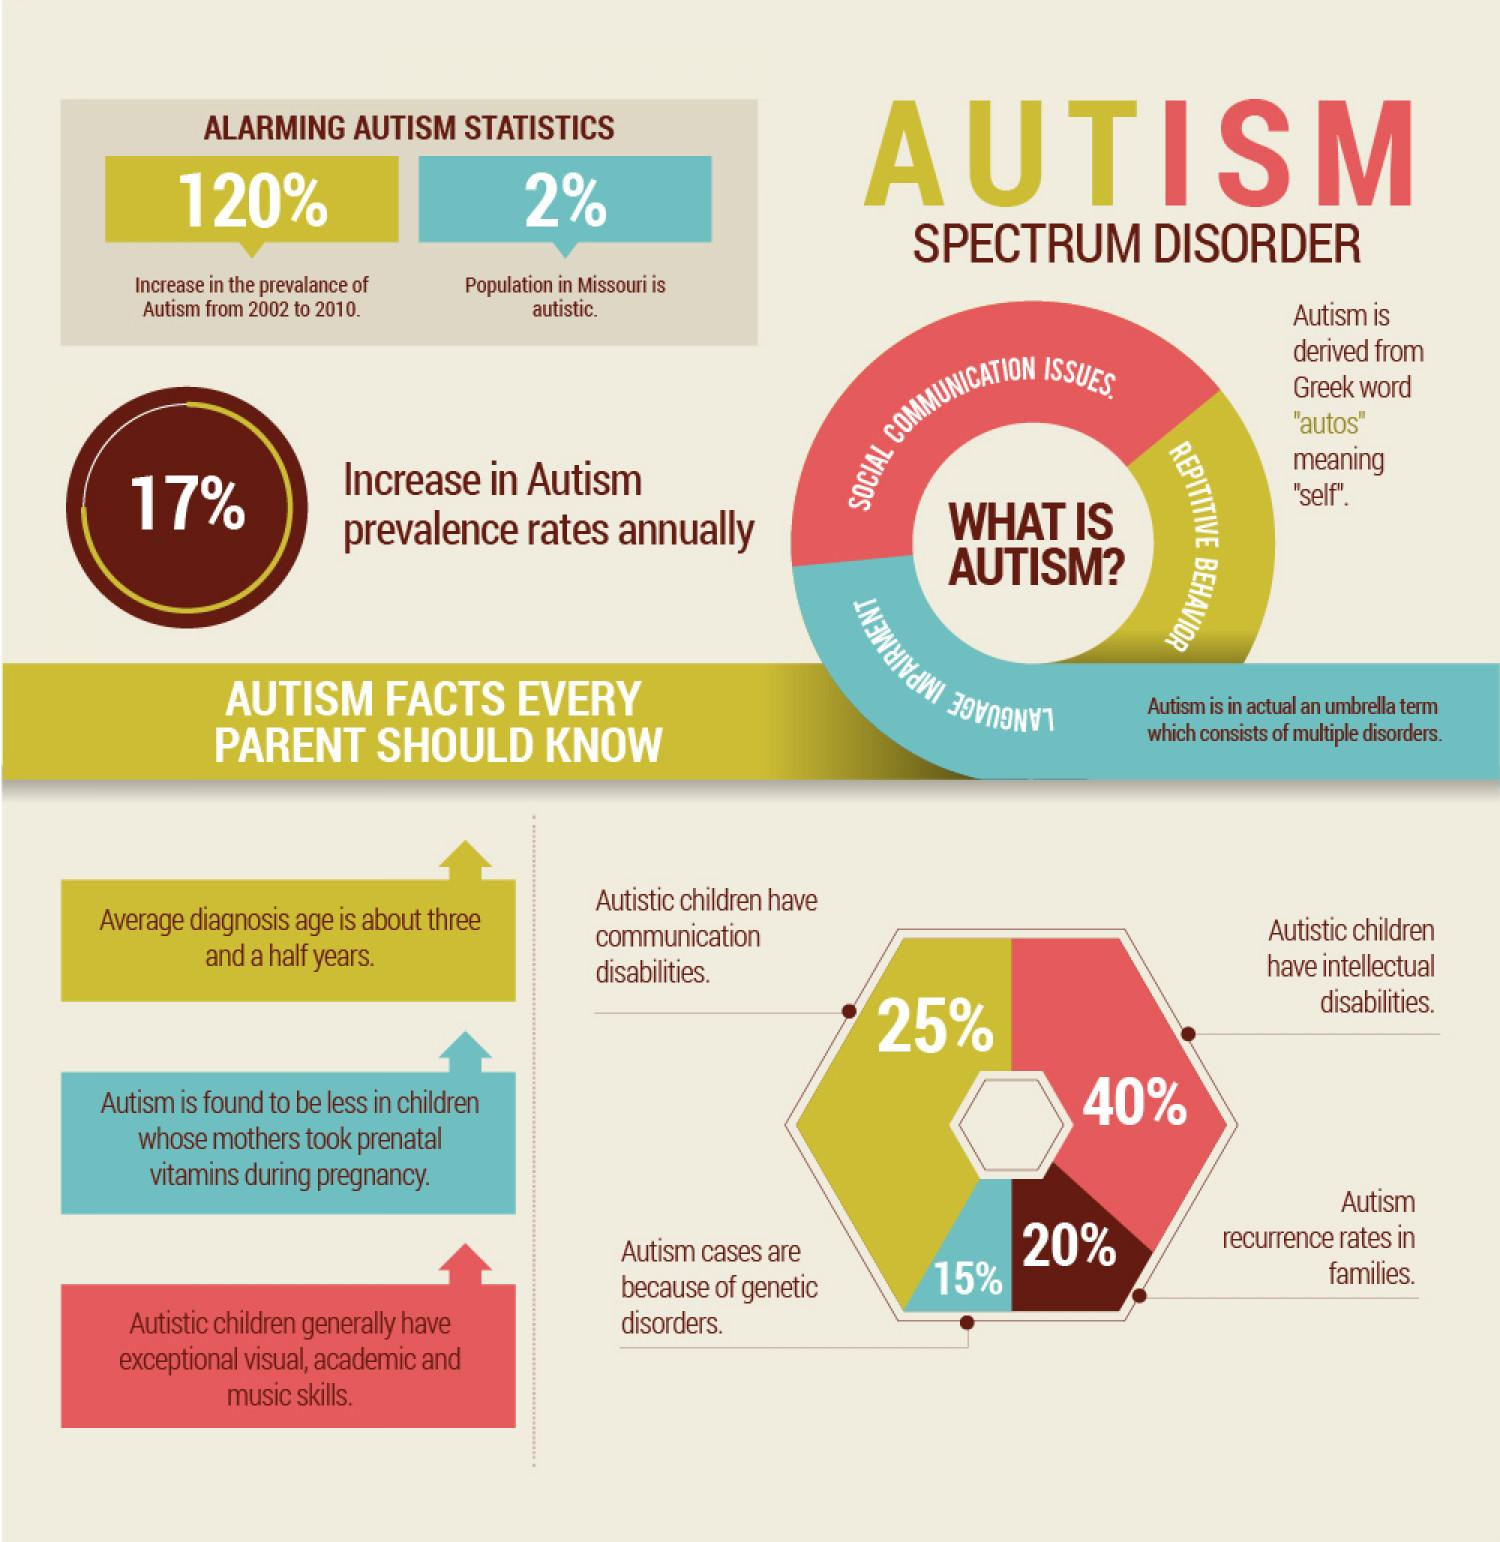Mention a couple of crucial points in this snapshot. According to recent studies, approximately 40% of Autistic children also have intellectual disabilities. The word 'autos' in Greek means 'self'. According to recent studies, approximately 15% of autism cases are caused by genetic disorders. The prevalence rates of autism have been found to increase by 17% annually. According to data, approximately 2% of the population in the state of Missouri is autistic. 